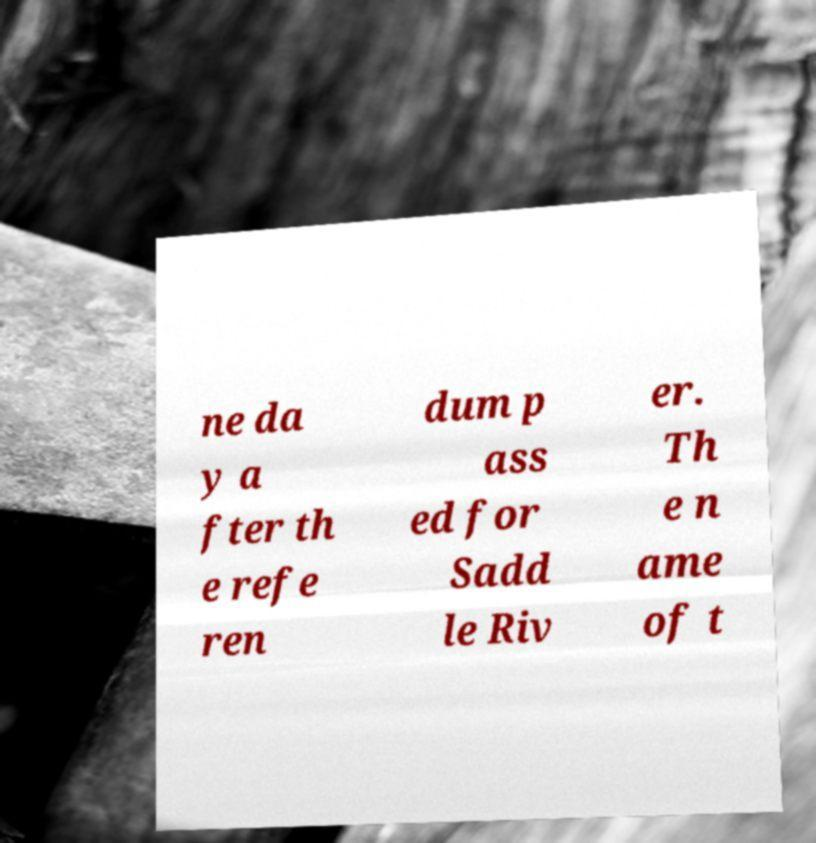For documentation purposes, I need the text within this image transcribed. Could you provide that? ne da y a fter th e refe ren dum p ass ed for Sadd le Riv er. Th e n ame of t 